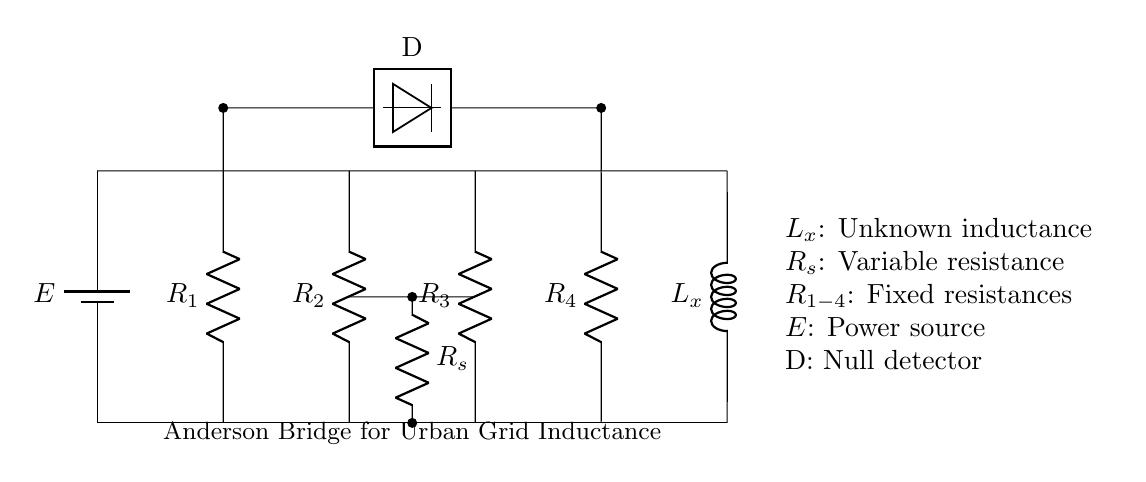What type of circuit is depicted? This circuit is known as an Anderson Bridge, which is specifically designed for measuring inductance. It balances the bridge to find the null point where the detector reads zero.
Answer: Anderson Bridge What components are used as resistors in this circuit? The resistors in this circuit are labeled R1, R2, R3, and R4. Each of these fixed resistances is integral to the operation of the bridge.
Answer: R1, R2, R3, R4 What does the null detector represent in the circuit? The null detector (labeled D) indicates when the bridge is balanced, meaning that no current flows through it at balance conditions.
Answer: Null Detector How many resistors are present in the circuit? There are four resistors connected in the circuit labeled R1, R2, R3, and R4.
Answer: Four What is the purpose of the variable resistance in the circuit? The variable resistance (labeled Rs) is used for tuning the circuit to achieve balance in the bridge condition, affecting the measurement of the unknown inductance (Lx).
Answer: Tuning What happens when the bridge is balanced? When the bridge is balanced, the current through the null detector is zero, indicating that the ratio of resistances is equal and allowing for the calculation of the unknown inductance (Lx).
Answer: Zero current What does Lx represent in the context of this circuit? Lx represents the unknown inductance that the circuit is designed to measure using the bridge method, allowing for precise calculations based on the known resistances.
Answer: Unknown inductance 